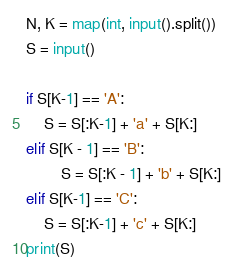<code> <loc_0><loc_0><loc_500><loc_500><_Python_>N, K = map(int, input().split())
S = input()

if S[K-1] == 'A':
    S = S[:K-1] + 'a' + S[K:]
elif S[K - 1] == 'B':
        S = S[:K - 1] + 'b' + S[K:]
elif S[K-1] == 'C':
    S = S[:K-1] + 'c' + S[K:]
print(S)</code> 